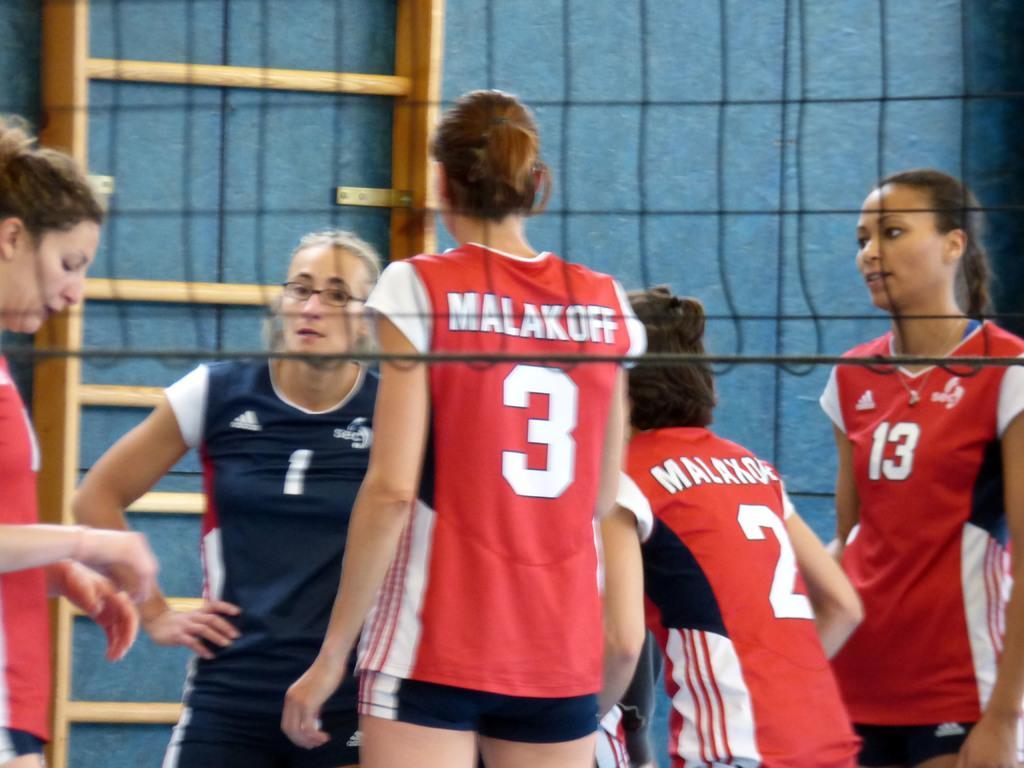In one or two sentences, can you explain what this image depicts? In this image we can see women standing. 